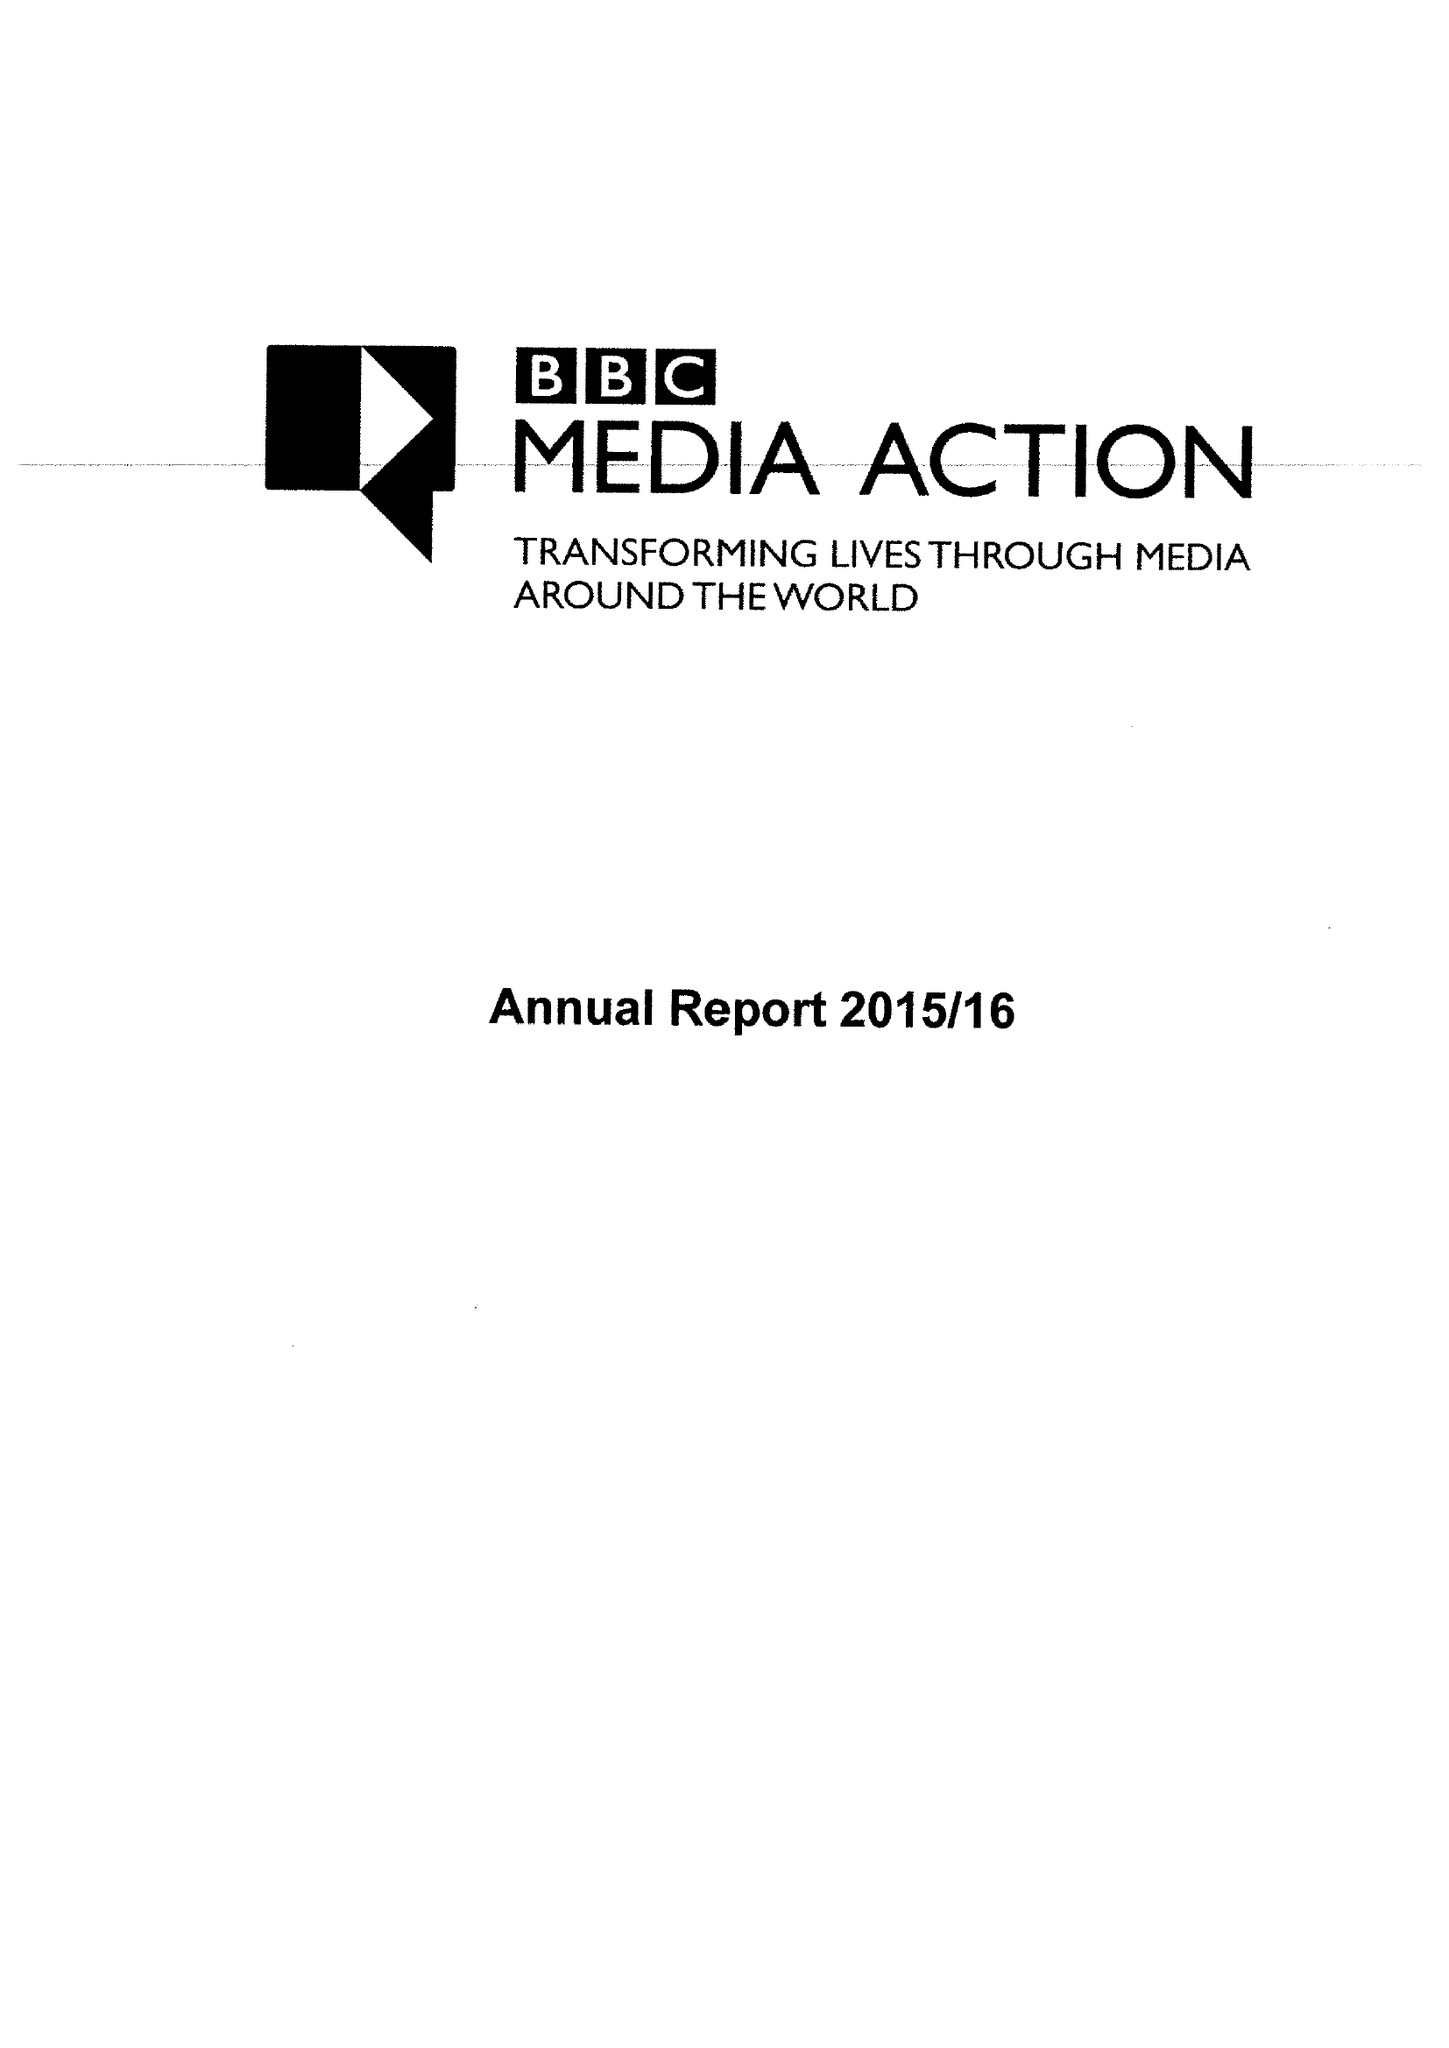What is the value for the charity_name?
Answer the question using a single word or phrase. Bbc Media Action 